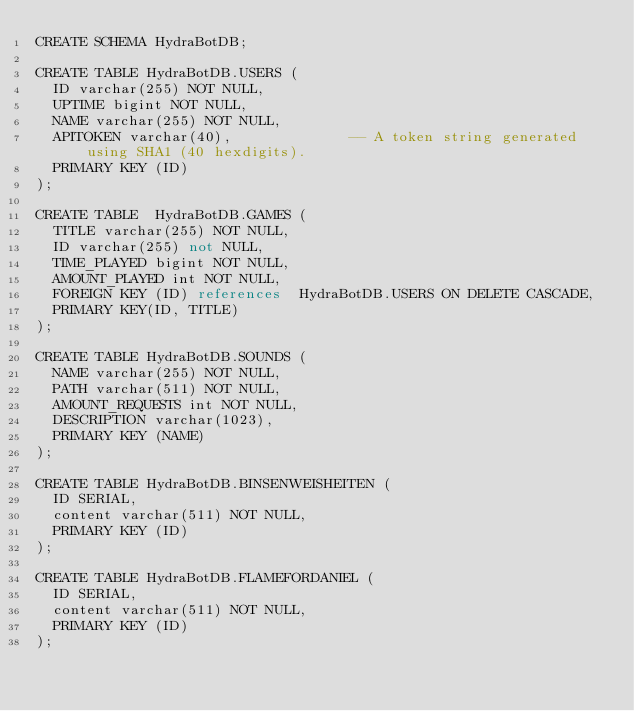Convert code to text. <code><loc_0><loc_0><loc_500><loc_500><_SQL_>CREATE SCHEMA HydraBotDB;

CREATE TABLE HydraBotDB.USERS (
  ID varchar(255) NOT NULL,
  UPTIME bigint NOT NULL,
  NAME varchar(255) NOT NULL,
  APITOKEN varchar(40),              -- A token string generated using SHA1 (40 hexdigits).
  PRIMARY KEY (ID)
);

CREATE TABLE  HydraBotDB.GAMES (
  TITLE varchar(255) NOT NULL,
  ID varchar(255) not NULL,
  TIME_PLAYED bigint NOT NULL,
  AMOUNT_PLAYED int NOT NULL,
  FOREIGN KEY (ID) references  HydraBotDB.USERS ON DELETE CASCADE,
  PRIMARY KEY(ID, TITLE)
);

CREATE TABLE HydraBotDB.SOUNDS (
  NAME varchar(255) NOT NULL,
  PATH varchar(511) NOT NULL,
  AMOUNT_REQUESTS int NOT NULL,
  DESCRIPTION varchar(1023),
  PRIMARY KEY (NAME)
);

CREATE TABLE HydraBotDB.BINSENWEISHEITEN (
  ID SERIAL,
  content varchar(511) NOT NULL,
  PRIMARY KEY (ID)
);

CREATE TABLE HydraBotDB.FLAMEFORDANIEL (
  ID SERIAL,
  content varchar(511) NOT NULL,
  PRIMARY KEY (ID)
);
</code> 